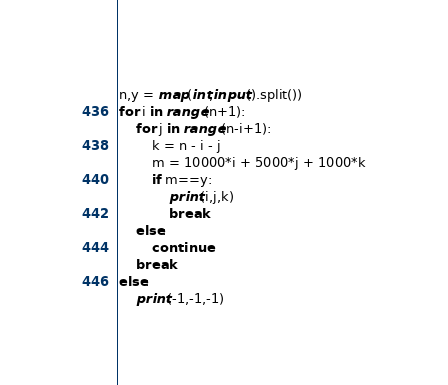Convert code to text. <code><loc_0><loc_0><loc_500><loc_500><_Python_>n,y = map(int,input().split())
for i in range(n+1):
    for j in range(n-i+1):
        k = n - i - j
        m = 10000*i + 5000*j + 1000*k
        if m==y:
            print(i,j,k)
            break
    else:
        continue
    break
else:
    print(-1,-1,-1)
</code> 